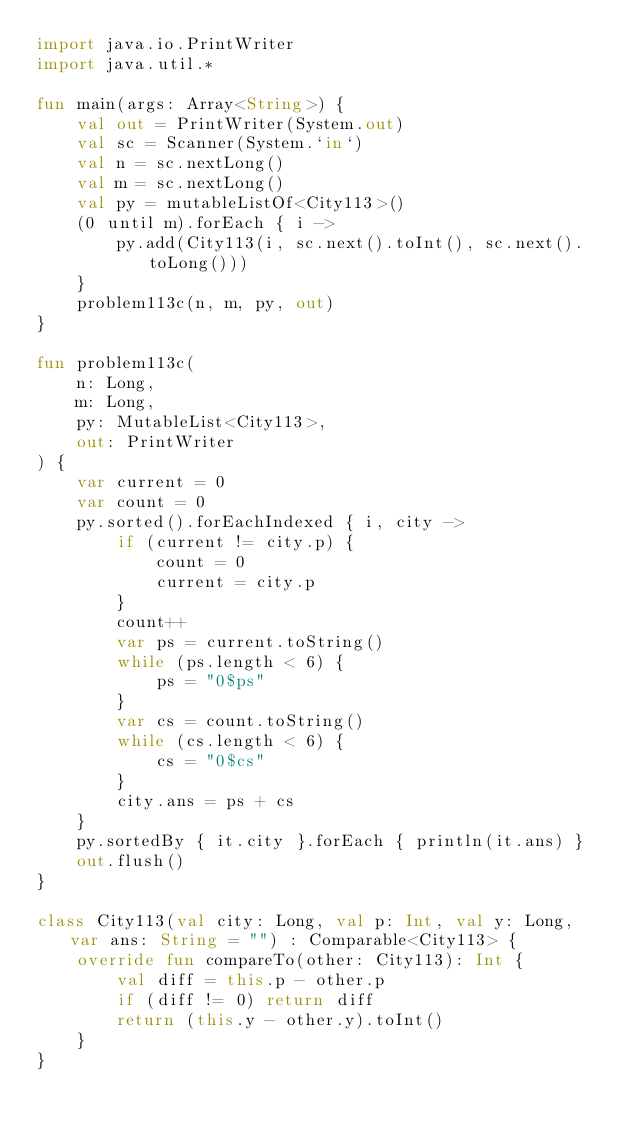<code> <loc_0><loc_0><loc_500><loc_500><_Kotlin_>import java.io.PrintWriter
import java.util.*

fun main(args: Array<String>) {
    val out = PrintWriter(System.out)
    val sc = Scanner(System.`in`)
    val n = sc.nextLong()
    val m = sc.nextLong()
    val py = mutableListOf<City113>()
    (0 until m).forEach { i ->
        py.add(City113(i, sc.next().toInt(), sc.next().toLong()))
    }
    problem113c(n, m, py, out)
}

fun problem113c(
    n: Long,
    m: Long,
    py: MutableList<City113>,
    out: PrintWriter
) {
    var current = 0
    var count = 0
    py.sorted().forEachIndexed { i, city ->
        if (current != city.p) {
            count = 0
            current = city.p
        }
        count++
        var ps = current.toString()
        while (ps.length < 6) {
            ps = "0$ps"
        }
        var cs = count.toString()
        while (cs.length < 6) {
            cs = "0$cs"
        }
        city.ans = ps + cs
    }
    py.sortedBy { it.city }.forEach { println(it.ans) }
    out.flush()
}

class City113(val city: Long, val p: Int, val y: Long, var ans: String = "") : Comparable<City113> {
    override fun compareTo(other: City113): Int {
        val diff = this.p - other.p
        if (diff != 0) return diff
        return (this.y - other.y).toInt()
    }
}</code> 